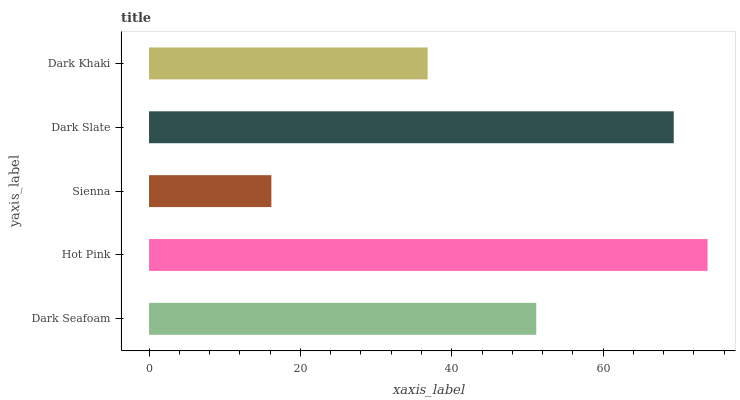Is Sienna the minimum?
Answer yes or no. Yes. Is Hot Pink the maximum?
Answer yes or no. Yes. Is Hot Pink the minimum?
Answer yes or no. No. Is Sienna the maximum?
Answer yes or no. No. Is Hot Pink greater than Sienna?
Answer yes or no. Yes. Is Sienna less than Hot Pink?
Answer yes or no. Yes. Is Sienna greater than Hot Pink?
Answer yes or no. No. Is Hot Pink less than Sienna?
Answer yes or no. No. Is Dark Seafoam the high median?
Answer yes or no. Yes. Is Dark Seafoam the low median?
Answer yes or no. Yes. Is Hot Pink the high median?
Answer yes or no. No. Is Hot Pink the low median?
Answer yes or no. No. 